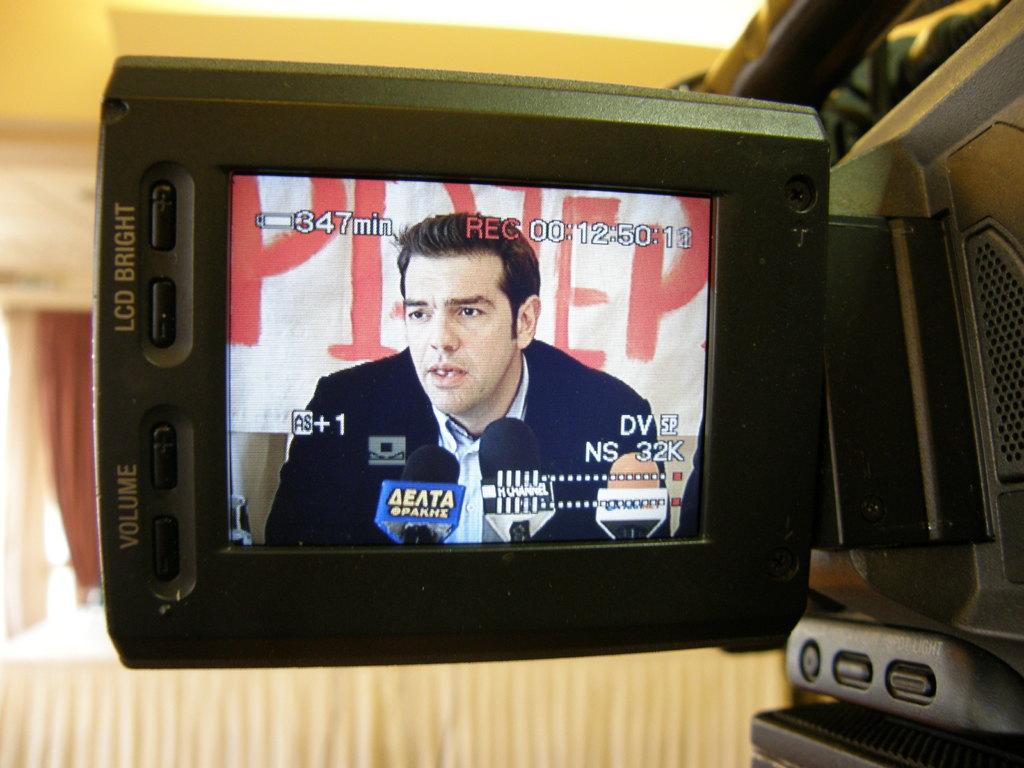How many minutes is displayed next to the battery icon?
Offer a terse response. 347. 